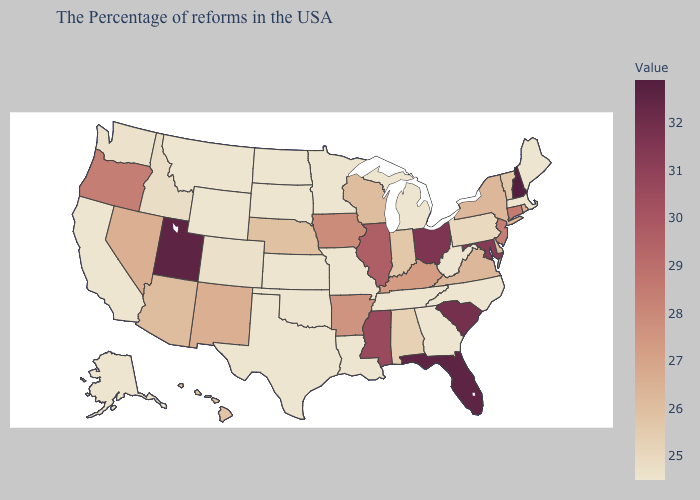Does Ohio have the highest value in the MidWest?
Quick response, please. Yes. Which states have the lowest value in the South?
Quick response, please. North Carolina, West Virginia, Georgia, Tennessee, Louisiana, Oklahoma, Texas. Among the states that border Vermont , does Massachusetts have the lowest value?
Keep it brief. Yes. Does Kentucky have the lowest value in the USA?
Quick response, please. No. Does the map have missing data?
Be succinct. No. 